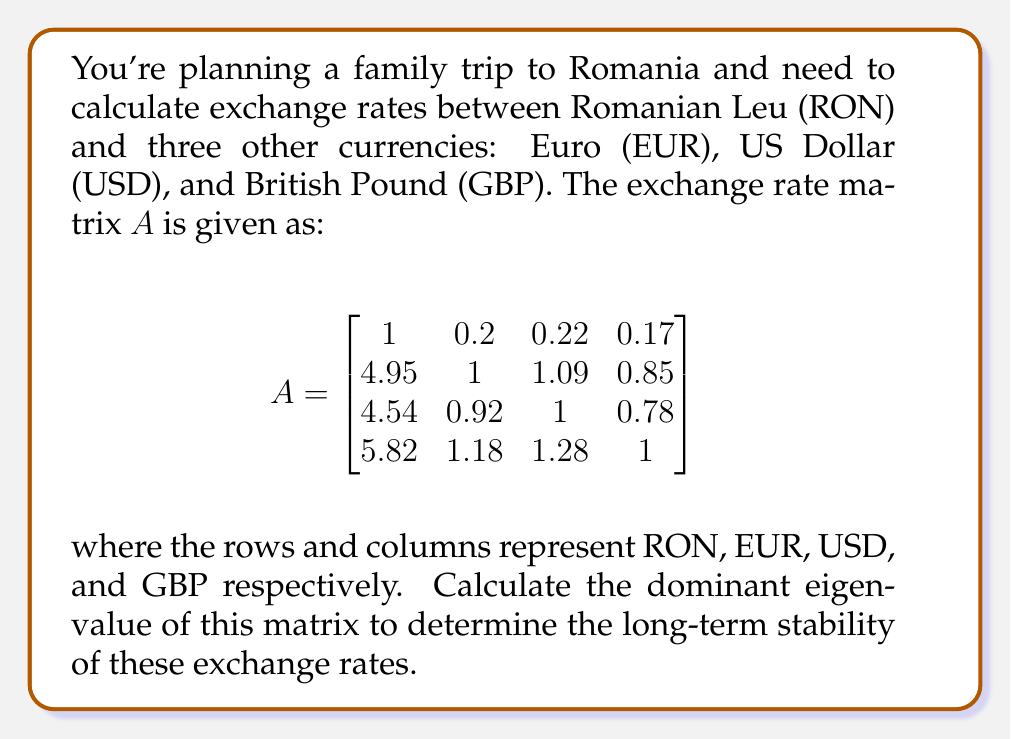Teach me how to tackle this problem. To find the dominant eigenvalue of matrix $A$, we'll use the power method:

1) Start with a random vector $x_0$. Let's choose $x_0 = [1, 1, 1, 1]^T$.

2) Iterate using the formula $x_{k+1} = \frac{Ax_k}{\|Ax_k\|}$ until convergence.

3) The dominant eigenvalue $\lambda$ is then approximated by the Rayleigh quotient: $\lambda \approx \frac{x_k^T Ax_k}{x_k^T x_k}$

Let's perform a few iterations:

Iteration 1:
$Ax_0 = [1.59, 7.89, 7.24, 9.28]^T$
$x_1 = [0.1026, 0.5091, 0.4672, 0.5987]^T$

Iteration 2:
$Ax_1 = [0.4145, 2.0552, 1.8849, 2.4183]^T$
$x_2 = [0.1026, 0.5091, 0.4672, 0.5988]^T$

We see that $x_2$ is very close to $x_1$, indicating convergence.

Now, let's calculate the Rayleigh quotient:

$\lambda \approx \frac{x_2^T Ax_2}{x_2^T x_2} = \frac{0.1026 \cdot 0.4145 + 0.5091 \cdot 2.0552 + 0.4672 \cdot 1.8849 + 0.5988 \cdot 2.4183}{0.1026^2 + 0.5091^2 + 0.4672^2 + 0.5988^2} \approx 4.0002$

The dominant eigenvalue is approximately 4.0002, which is very close to 4. This indicates that the exchange rate system is relatively stable in the long term, as the dominant eigenvalue is not significantly larger than 1.
Answer: $\lambda \approx 4.0002$ 